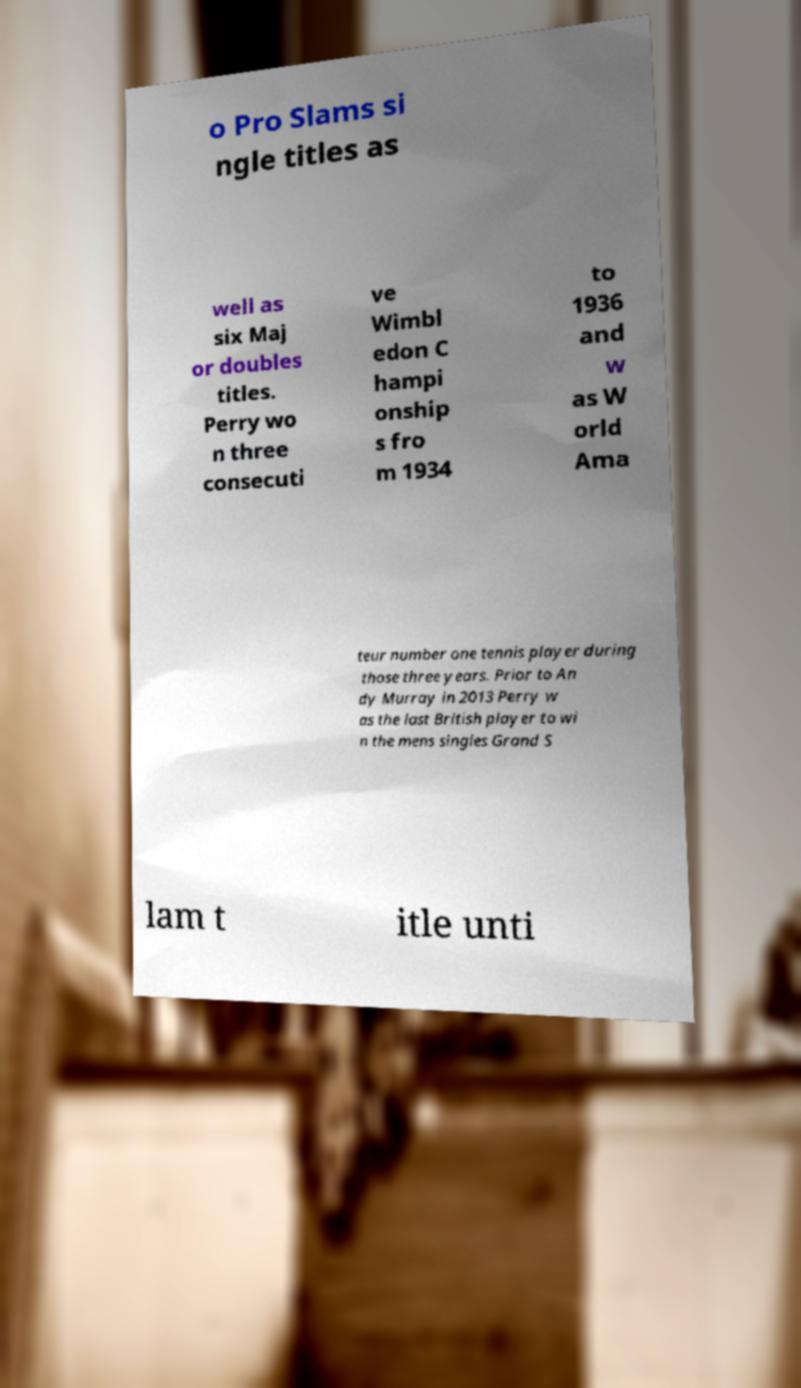Can you read and provide the text displayed in the image?This photo seems to have some interesting text. Can you extract and type it out for me? o Pro Slams si ngle titles as well as six Maj or doubles titles. Perry wo n three consecuti ve Wimbl edon C hampi onship s fro m 1934 to 1936 and w as W orld Ama teur number one tennis player during those three years. Prior to An dy Murray in 2013 Perry w as the last British player to wi n the mens singles Grand S lam t itle unti 